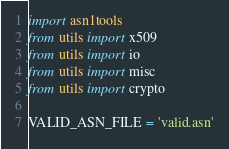<code> <loc_0><loc_0><loc_500><loc_500><_Python_>import asn1tools
from utils import x509
from utils import io
from utils import misc
from utils import crypto

VALID_ASN_FILE = 'valid.asn'</code> 